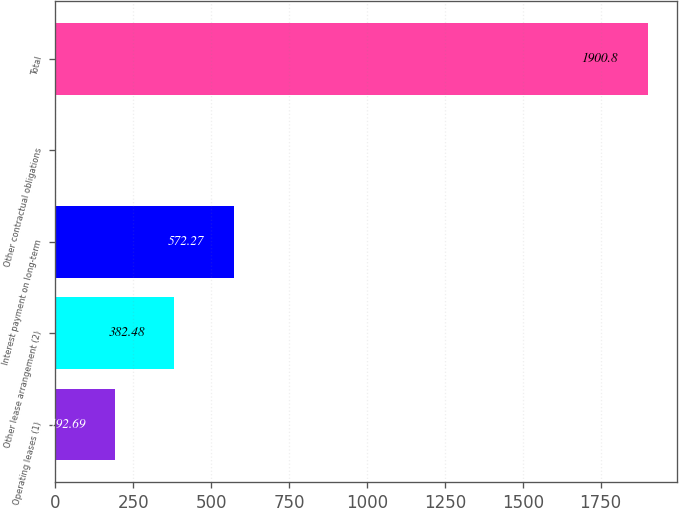Convert chart to OTSL. <chart><loc_0><loc_0><loc_500><loc_500><bar_chart><fcel>Operating leases (1)<fcel>Other lease arrangement (2)<fcel>Interest payment on long-term<fcel>Other contractual obligations<fcel>Total<nl><fcel>192.69<fcel>382.48<fcel>572.27<fcel>2.9<fcel>1900.8<nl></chart> 